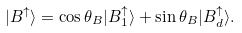Convert formula to latex. <formula><loc_0><loc_0><loc_500><loc_500>| B ^ { \uparrow } \rangle = \cos \theta _ { B } | B _ { 1 } ^ { \uparrow } \rangle + \sin \theta _ { B } | B _ { d } ^ { \uparrow } \rangle .</formula> 